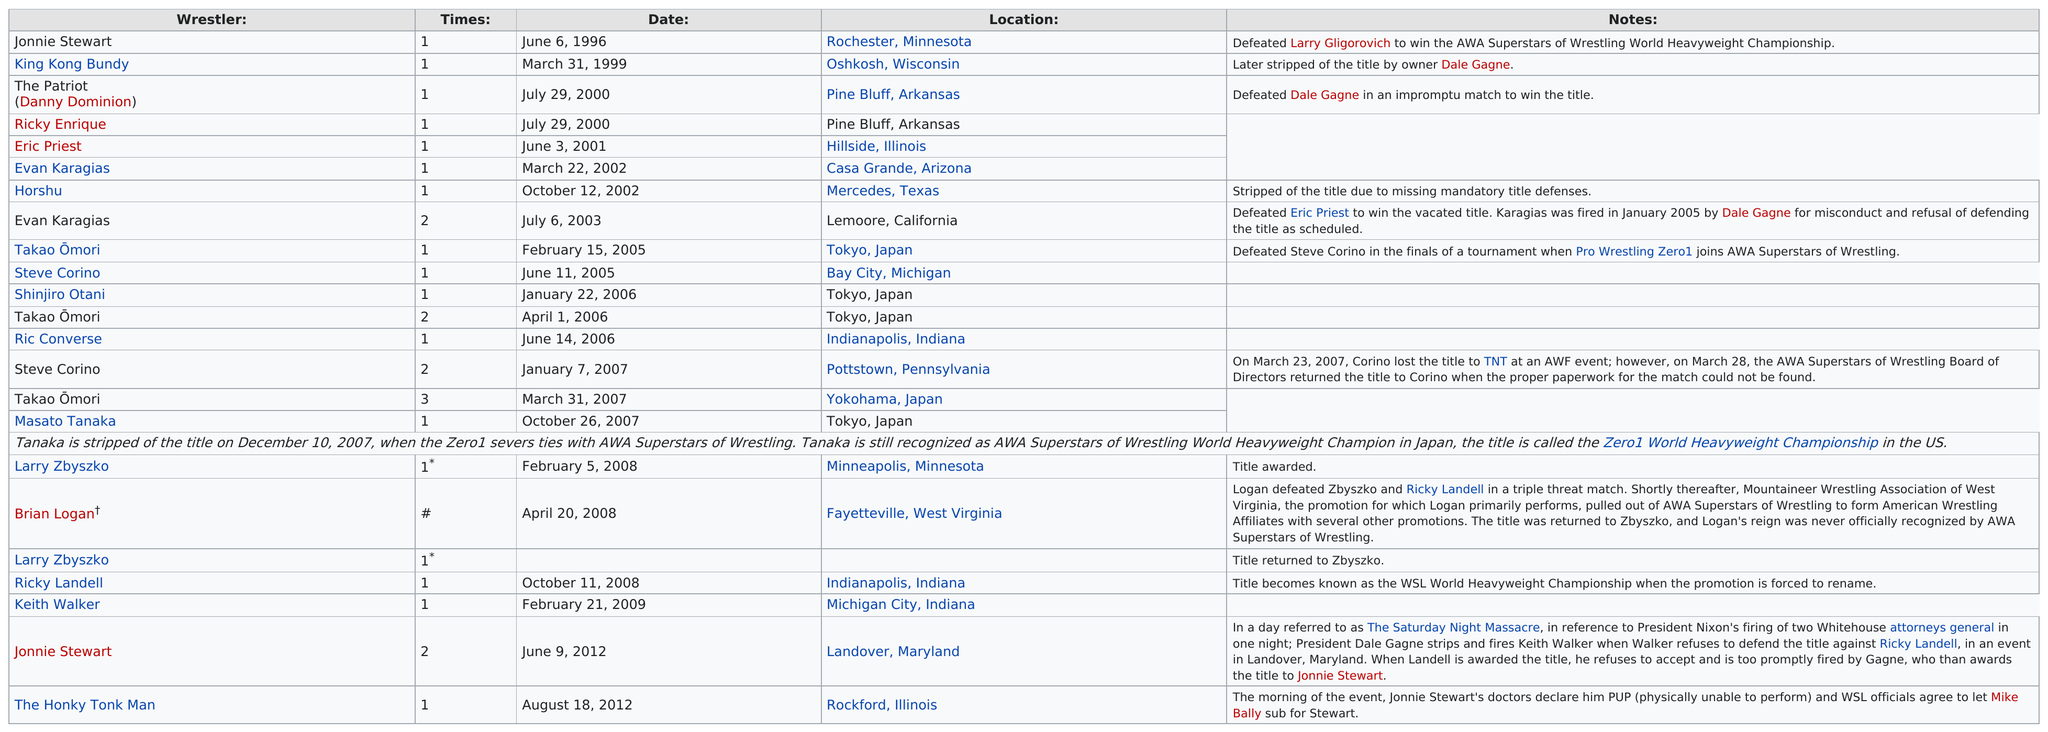Outline some significant characteristics in this image. On June 11, 2005, Steve Corino won his first World Series of Lucha Libre (WSOL) title. The Honky Tonk Man is the last wrestler to hold the title. Evan Karagias is the only person listed on July 6, 2003. The person who is listed before Keith Walker is Ricky Landell. Ricky Landell has held the WSL title 1 time. 